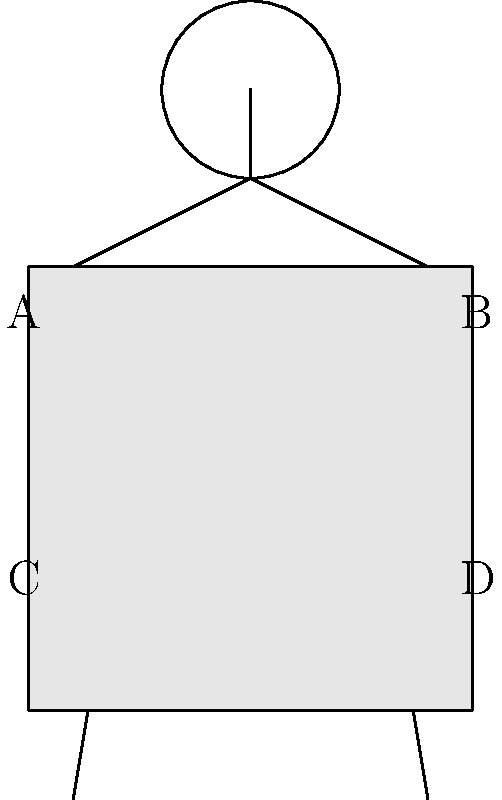In judo, proper grip positions are crucial for executing techniques effectively. Referring to the diagram of a judoka wearing a gi, which combination of grip positions is most commonly used for a basic right-handed grip in competitive judo? To determine the correct grip positions for a basic right-handed grip in competitive judo, let's follow these steps:

1. Understand the grip positions:
   A: Left lapel (high)
   B: Right sleeve (high)
   C: Left lapel (low)
   D: Right sleeve (low)

2. Consider the principles of a right-handed grip:
   - The dominant (right) hand typically grips the opponent's sleeve
   - The non-dominant (left) hand usually grips the opponent's lapel

3. Analyze the effectiveness of each position:
   - High grips (A and B) provide more control but can be easier for the opponent to break
   - Low grips (C and D) offer stability but may limit some throwing techniques

4. Apply competitive judo strategy:
   - A high lapel grip with the left hand allows for better control of the opponent's upper body
   - A low sleeve grip with the right hand provides stability and sets up for various throwing techniques

5. Consider the influence of François Gauthier-Drapeau's style:
   - As a right-handed judoka, he often employs a high lapel, low sleeve grip combination

Based on these considerations, the most common and effective basic right-handed grip combination in competitive judo would be positions A (left hand on high lapel) and D (right hand on low sleeve).
Answer: A and D 